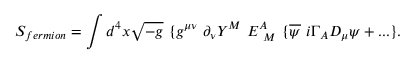Convert formula to latex. <formula><loc_0><loc_0><loc_500><loc_500>S _ { f e r m i o n } = \int d ^ { 4 } x \sqrt { - g } \{ g ^ { \mu \nu } \partial _ { \nu } Y ^ { M } E _ { M } ^ { A } \{ \overline { \psi } i \Gamma _ { A } D _ { \mu } \psi + \dots \} .</formula> 